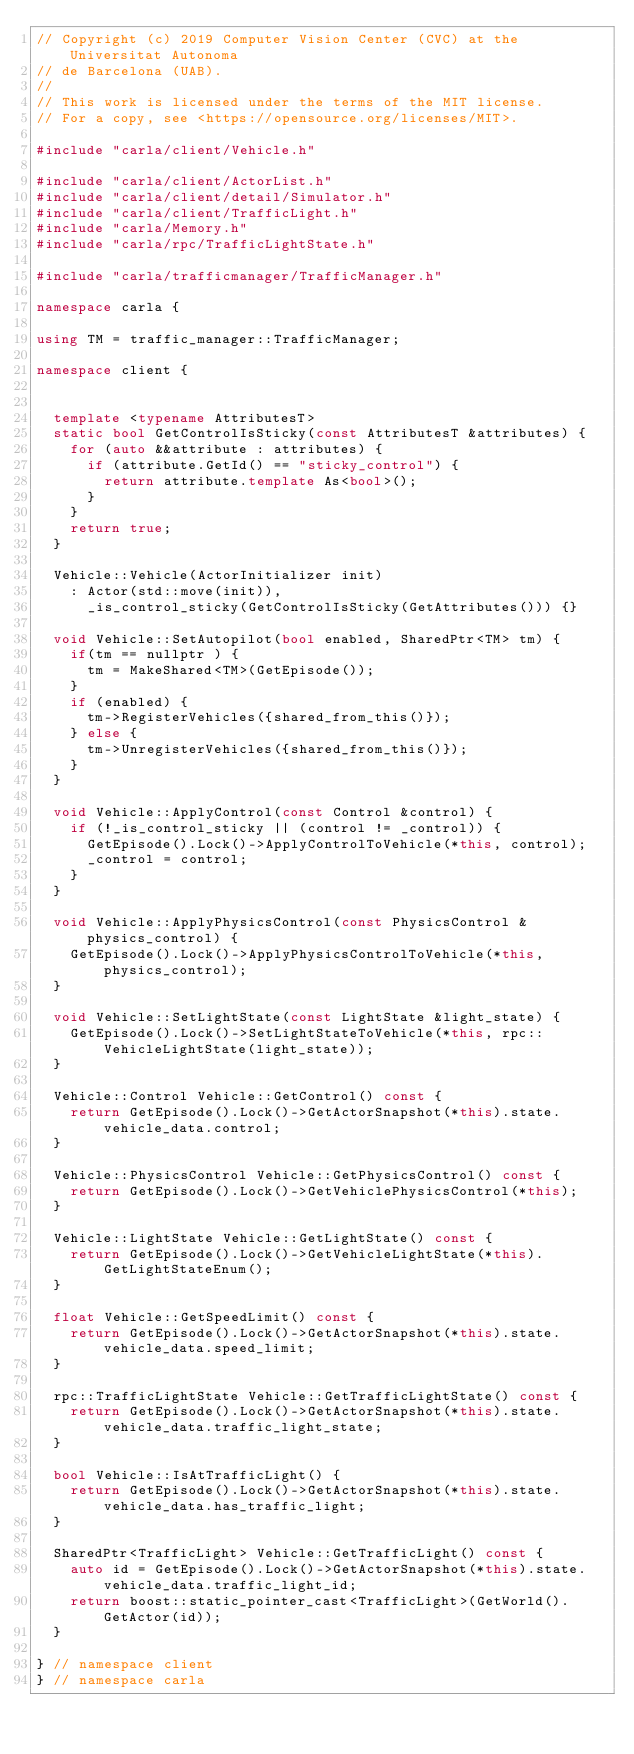<code> <loc_0><loc_0><loc_500><loc_500><_C++_>// Copyright (c) 2019 Computer Vision Center (CVC) at the Universitat Autonoma
// de Barcelona (UAB).
//
// This work is licensed under the terms of the MIT license.
// For a copy, see <https://opensource.org/licenses/MIT>.

#include "carla/client/Vehicle.h"

#include "carla/client/ActorList.h"
#include "carla/client/detail/Simulator.h"
#include "carla/client/TrafficLight.h"
#include "carla/Memory.h"
#include "carla/rpc/TrafficLightState.h"

#include "carla/trafficmanager/TrafficManager.h"

namespace carla {

using TM = traffic_manager::TrafficManager;

namespace client {


  template <typename AttributesT>
  static bool GetControlIsSticky(const AttributesT &attributes) {
    for (auto &&attribute : attributes) {
      if (attribute.GetId() == "sticky_control") {
        return attribute.template As<bool>();
      }
    }
    return true;
  }

  Vehicle::Vehicle(ActorInitializer init)
    : Actor(std::move(init)),
      _is_control_sticky(GetControlIsSticky(GetAttributes())) {}

  void Vehicle::SetAutopilot(bool enabled, SharedPtr<TM> tm) {
    if(tm == nullptr ) {
      tm = MakeShared<TM>(GetEpisode());
    }
    if (enabled) {
      tm->RegisterVehicles({shared_from_this()});
    } else {
      tm->UnregisterVehicles({shared_from_this()});
    }
  }

  void Vehicle::ApplyControl(const Control &control) {
    if (!_is_control_sticky || (control != _control)) {
      GetEpisode().Lock()->ApplyControlToVehicle(*this, control);
      _control = control;
    }
  }

  void Vehicle::ApplyPhysicsControl(const PhysicsControl &physics_control) {
    GetEpisode().Lock()->ApplyPhysicsControlToVehicle(*this, physics_control);
  }

  void Vehicle::SetLightState(const LightState &light_state) {
    GetEpisode().Lock()->SetLightStateToVehicle(*this, rpc::VehicleLightState(light_state));
  }

  Vehicle::Control Vehicle::GetControl() const {
    return GetEpisode().Lock()->GetActorSnapshot(*this).state.vehicle_data.control;
  }

  Vehicle::PhysicsControl Vehicle::GetPhysicsControl() const {
    return GetEpisode().Lock()->GetVehiclePhysicsControl(*this);
  }

  Vehicle::LightState Vehicle::GetLightState() const {
    return GetEpisode().Lock()->GetVehicleLightState(*this).GetLightStateEnum();
  }

  float Vehicle::GetSpeedLimit() const {
    return GetEpisode().Lock()->GetActorSnapshot(*this).state.vehicle_data.speed_limit;
  }

  rpc::TrafficLightState Vehicle::GetTrafficLightState() const {
    return GetEpisode().Lock()->GetActorSnapshot(*this).state.vehicle_data.traffic_light_state;
  }

  bool Vehicle::IsAtTrafficLight() {
    return GetEpisode().Lock()->GetActorSnapshot(*this).state.vehicle_data.has_traffic_light;
  }

  SharedPtr<TrafficLight> Vehicle::GetTrafficLight() const {
    auto id = GetEpisode().Lock()->GetActorSnapshot(*this).state.vehicle_data.traffic_light_id;
    return boost::static_pointer_cast<TrafficLight>(GetWorld().GetActor(id));
  }

} // namespace client
} // namespace carla
</code> 